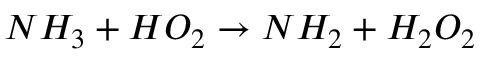<formula> <loc_0><loc_0><loc_500><loc_500>N H _ { 3 } + H O _ { 2 } \rightarrow N H _ { 2 } + H _ { 2 } O _ { 2 }</formula> 